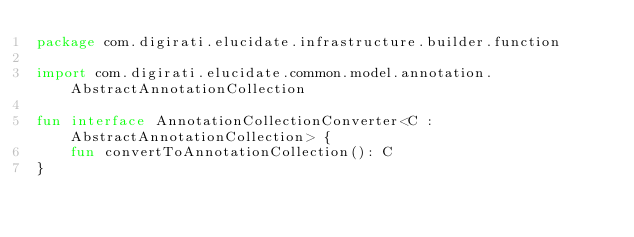<code> <loc_0><loc_0><loc_500><loc_500><_Kotlin_>package com.digirati.elucidate.infrastructure.builder.function

import com.digirati.elucidate.common.model.annotation.AbstractAnnotationCollection

fun interface AnnotationCollectionConverter<C : AbstractAnnotationCollection> {
    fun convertToAnnotationCollection(): C
}</code> 